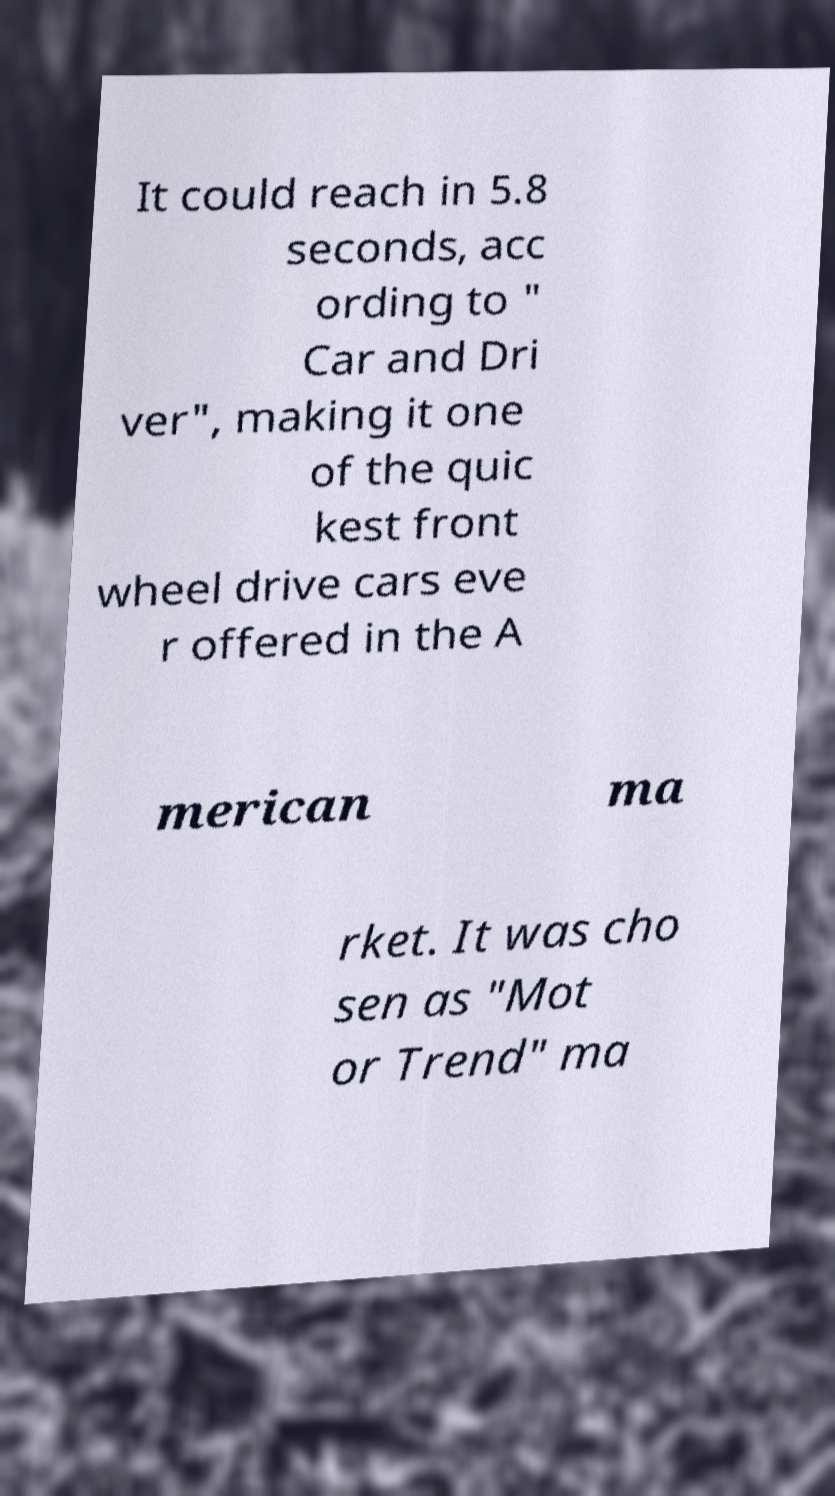What messages or text are displayed in this image? I need them in a readable, typed format. It could reach in 5.8 seconds, acc ording to " Car and Dri ver", making it one of the quic kest front wheel drive cars eve r offered in the A merican ma rket. It was cho sen as "Mot or Trend" ma 